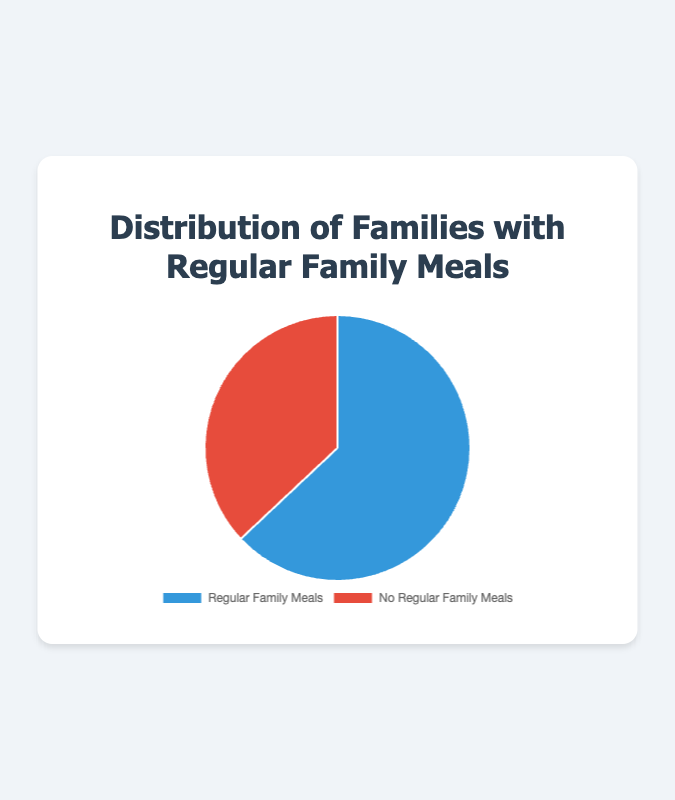What's the percentage of families with regular family meals? According to the pie chart, the percentage of families with regular family meals is given directly as part of the data.
Answer: 63% Which category has the higher percentage of families, regular family meals or no regular family meals? The pie chart shows 63% for families with regular family meals and 37% for families without regular family meals. 63% is greater than 37%.
Answer: Regular family meals What is the difference in percentage points between families with regular family meals and those without? Subtract the percentage of families without regular family meals (37%) from the percentage of families with regular family meals (63%). 63% - 37% = 26%.
Answer: 26% What fraction of families do not have regular family meals? Convert the percentage of families without regular family meals (37%) into a fraction by dividing by 100. 37% is 37/100, which simplifies to 37/100 or approximately 0.37.
Answer: 0.37 What visual colors represent families with and without regular family meals in the pie chart? The pie chart uses blue to represent families with regular family meals and red to represent families without regular family meals.
Answer: Blue for regular, red for no regular How many times larger is the percentage of families with regular family meals compared to those without? Divide the percentage of families with regular family meals (63%) by the percentage of families without (37%). 63% / 37% ≈ 1.70, meaning it is 1.70 times larger.
Answer: 1.70 times What's the sum of the percentages for both categories? Add the percentages of families with regular family meals (63%) and those without (37%). 63% + 37% = 100%.
Answer: 100% If you were to visualize the percentages as a ratio, what would it be for families with regular versus no regular family meals? The ratio is calculated by dividing the percentages. For families with regular family meals (63%) to those without (37%), the ratio is 63:37.
Answer: 63:37 Which segment of the pie chart would have a larger slice, and by how much, if represented in degrees? A pie chart is a full circle with 360 degrees. The slice for regular family meals is (63/100) * 360 = 226.8°, and for no regular family meals is (37/100) * 360 = 133.2°. 226.8° - 133.2° = 93.6°, so the regular family meals slice is larger by 93.6°.
Answer: 93.6° Is the percentage of families with regular family meals more than half? The percentage of families with regular family meals is 63%, which is greater than 50%.
Answer: Yes 